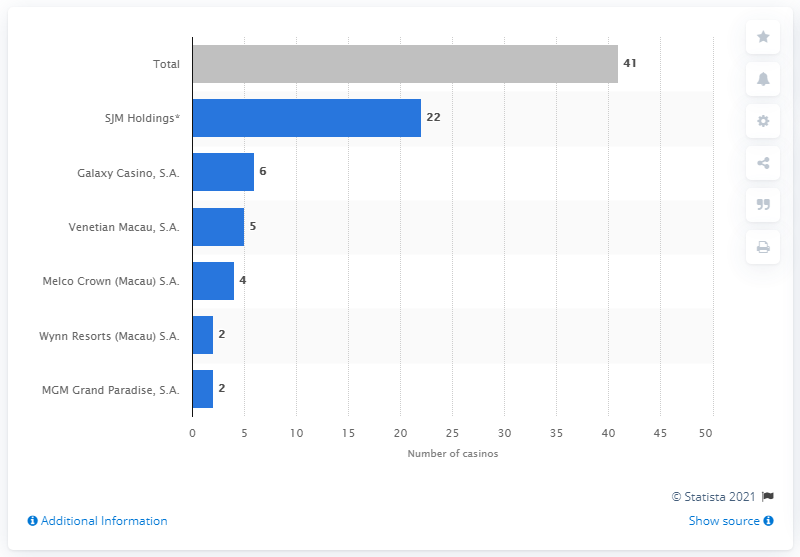List a handful of essential elements in this visual. In 2020, SJM Holdings owned a total of 22 casinos. 